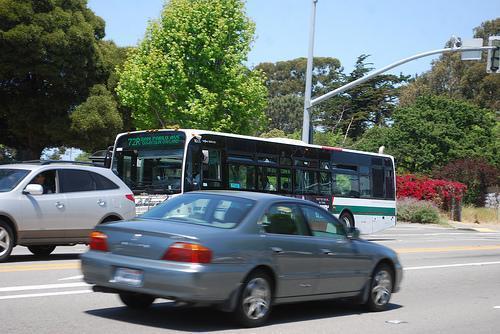How many vehicles are there?
Give a very brief answer. 3. How many vehicles are driving left?
Give a very brief answer. 2. 